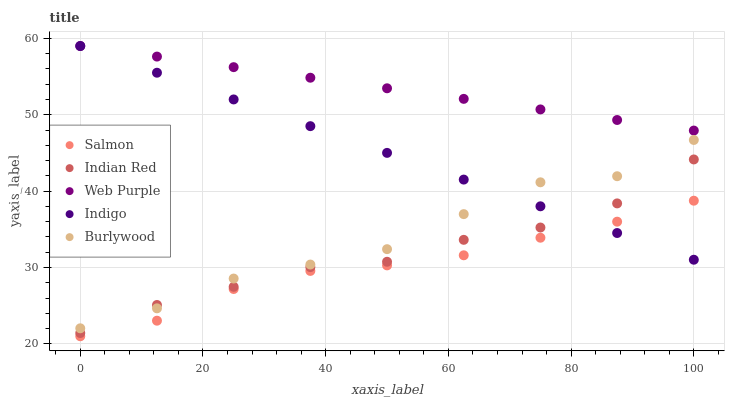Does Salmon have the minimum area under the curve?
Answer yes or no. Yes. Does Web Purple have the maximum area under the curve?
Answer yes or no. Yes. Does Indigo have the minimum area under the curve?
Answer yes or no. No. Does Indigo have the maximum area under the curve?
Answer yes or no. No. Is Web Purple the smoothest?
Answer yes or no. Yes. Is Burlywood the roughest?
Answer yes or no. Yes. Is Indigo the smoothest?
Answer yes or no. No. Is Indigo the roughest?
Answer yes or no. No. Does Salmon have the lowest value?
Answer yes or no. Yes. Does Indigo have the lowest value?
Answer yes or no. No. Does Web Purple have the highest value?
Answer yes or no. Yes. Does Salmon have the highest value?
Answer yes or no. No. Is Salmon less than Indian Red?
Answer yes or no. Yes. Is Web Purple greater than Salmon?
Answer yes or no. Yes. Does Indian Red intersect Burlywood?
Answer yes or no. Yes. Is Indian Red less than Burlywood?
Answer yes or no. No. Is Indian Red greater than Burlywood?
Answer yes or no. No. Does Salmon intersect Indian Red?
Answer yes or no. No. 